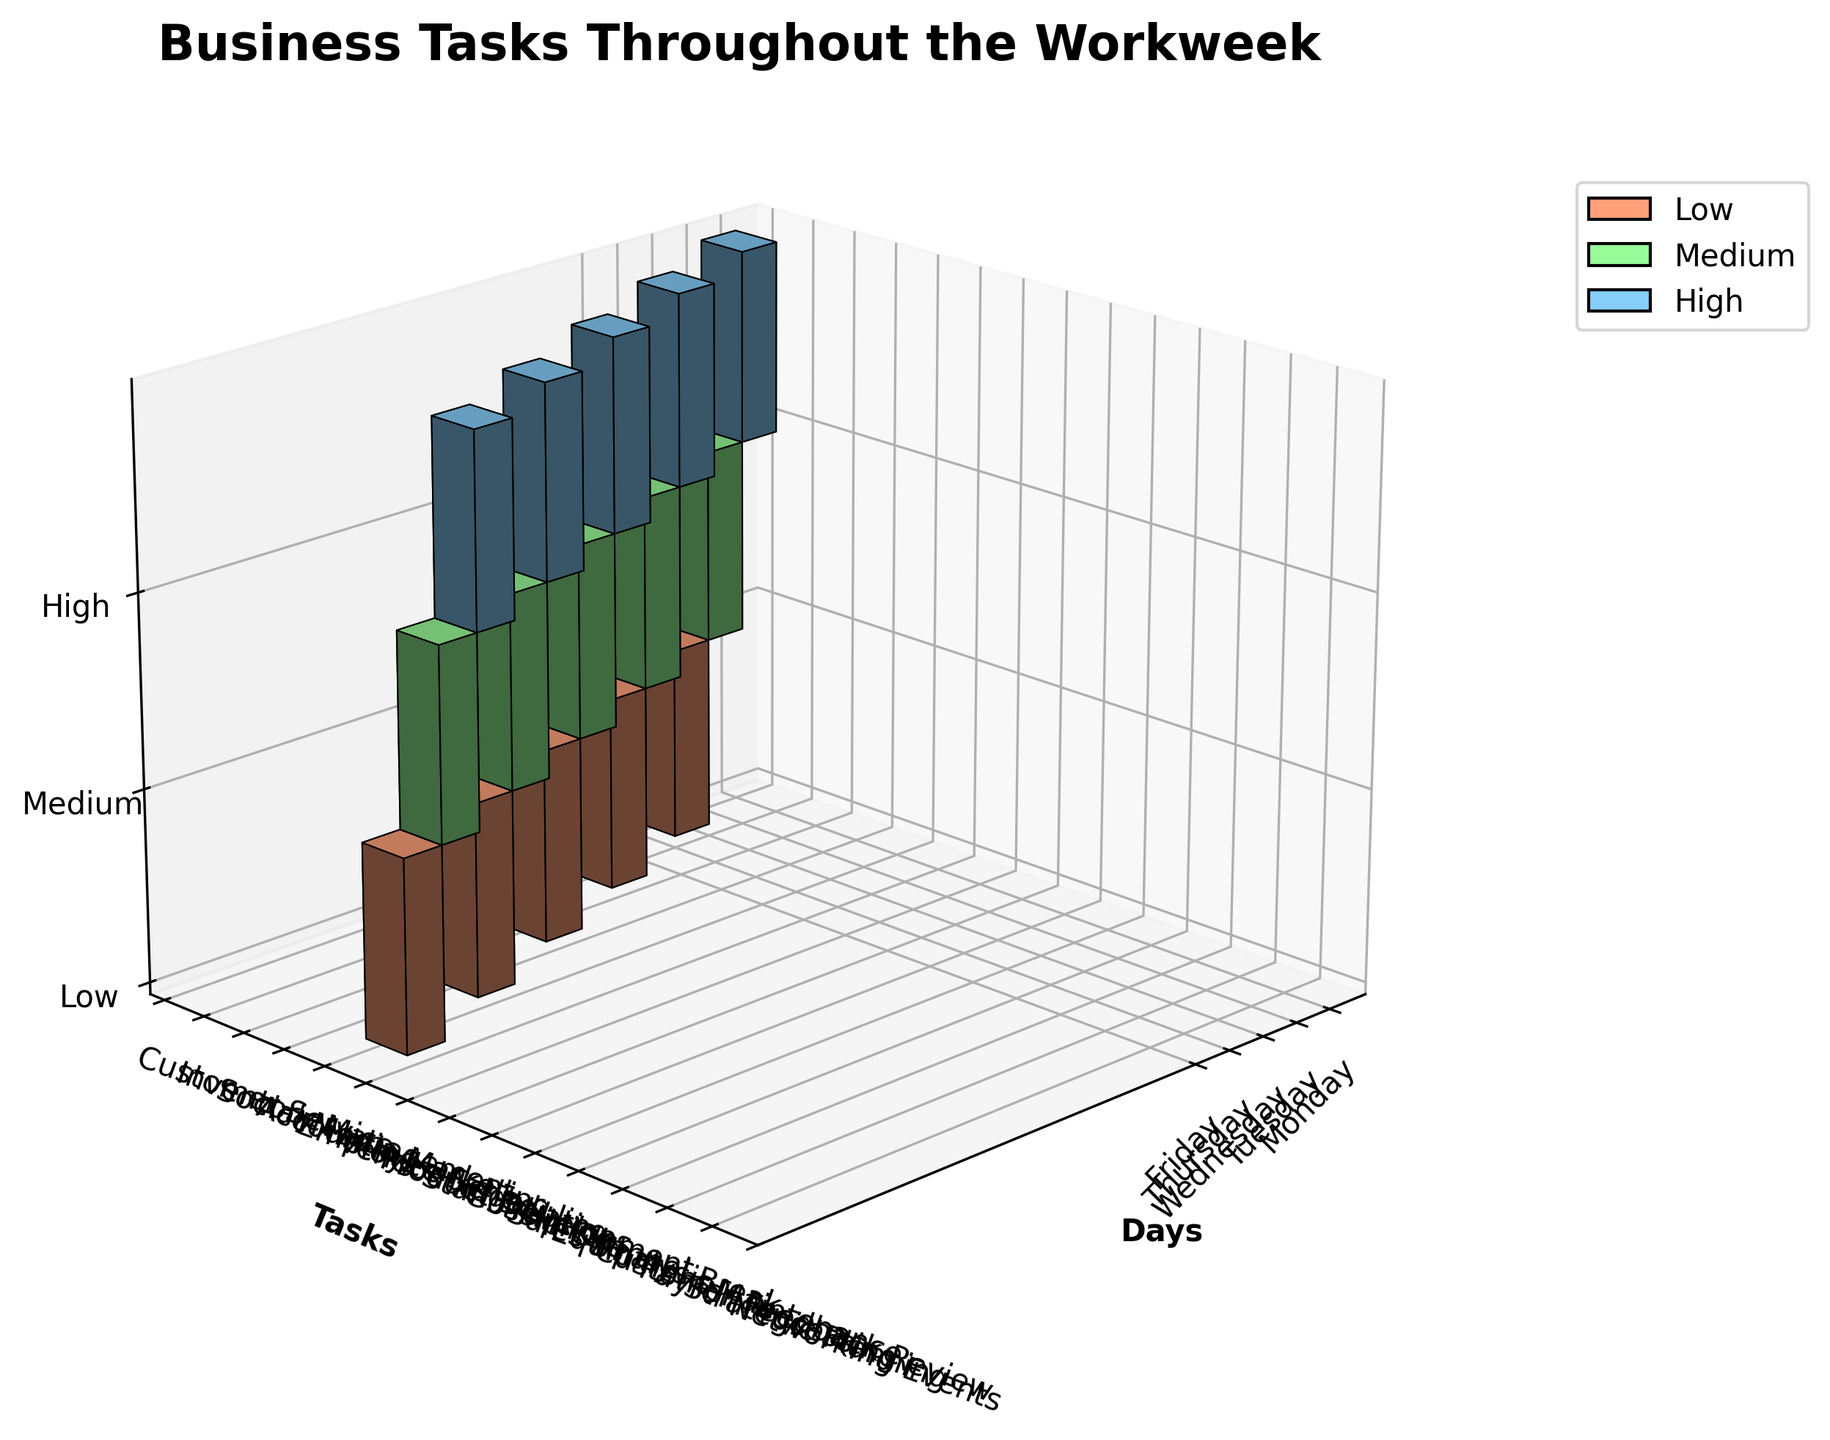How many tasks are classified as high importance on Friday? Look for the bars representing high importance (in blue) on Friday and count how many there are.
Answer: 1 Which day has the most high importance tasks? Compare the number of blue bars for each day in the figure to determine which day has the most.
Answer: Wednesday On which days is 'Customer Service' performed? Look for the bars related to 'Customer Service' and identify the days these bars appear on the x-axis.
Answer: Monday Which importance category has the most tasks on Monday? Check the color distribution (blue for high, light green for medium, peach for low) of the bars corresponding to Monday and identify the category with the most occurrences.
Answer: High Compare the time spent on high importance tasks on Monday to Wednesday. Identify the high importance tasks (blue bars) on Monday and Wednesday. Sum the length of these bars to compare the time spent.
Answer: Less on Monday How does the time spent on 'Inventory Management' compare across all days? Locate the bars for 'Inventory Management' and compare their heights (hours) across the days on the x-axis.
Answer: Only on Monday, 2 hours Which task has the same importance level throughout the week? Identify if there is a task that has bars of the same color (representing the same importance level) on each day it appears.
Answer: None Which task has the longest total time throughout the week? Sum the hours for each task across all days and find the one with the highest total.
Answer: Product Development How many total hours are spent on tasks with medium importance? Sum the hours of all medium importance tasks (light green bars) across all days.
Answer: 10 Is there a day on which only one importance level of tasks is completed? Check each day to see if all bars for that day are of the same color.
Answer: No 